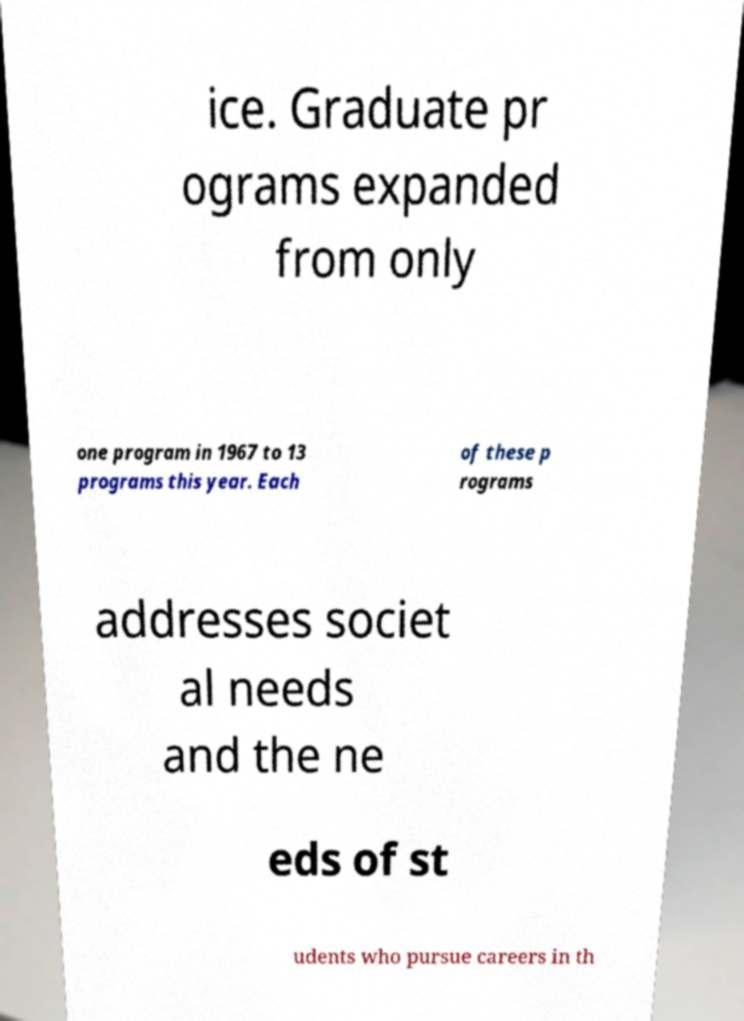Please read and relay the text visible in this image. What does it say? ice. Graduate pr ograms expanded from only one program in 1967 to 13 programs this year. Each of these p rograms addresses societ al needs and the ne eds of st udents who pursue careers in th 